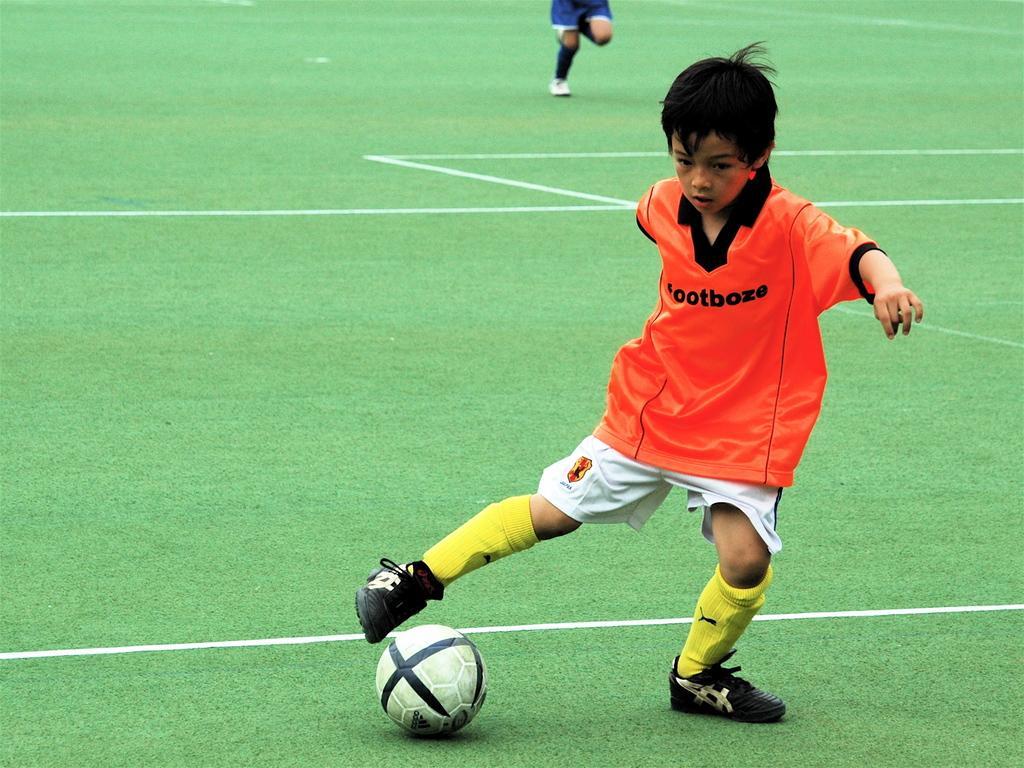Could you give a brief overview of what you see in this image? In this picture i could see a boy kicking the ball in the court with green grass. In the background i could see a person running. 